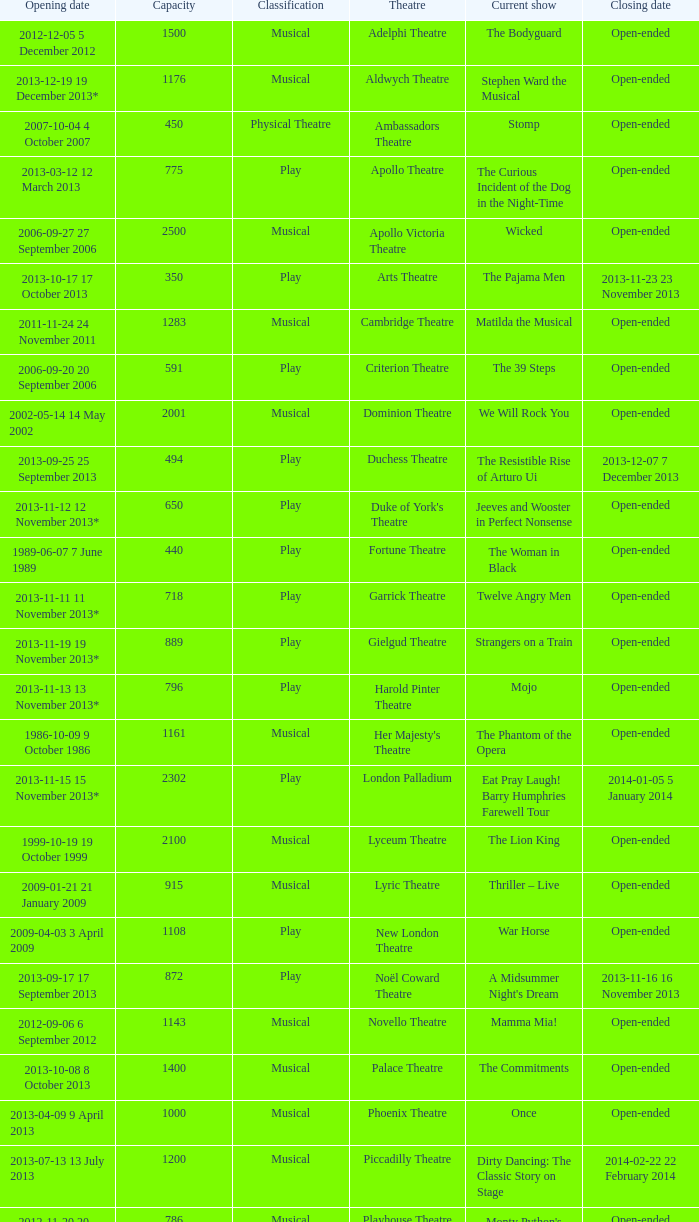What opening date has a capacity of 100? 2013-11-01 1 November 2013. 